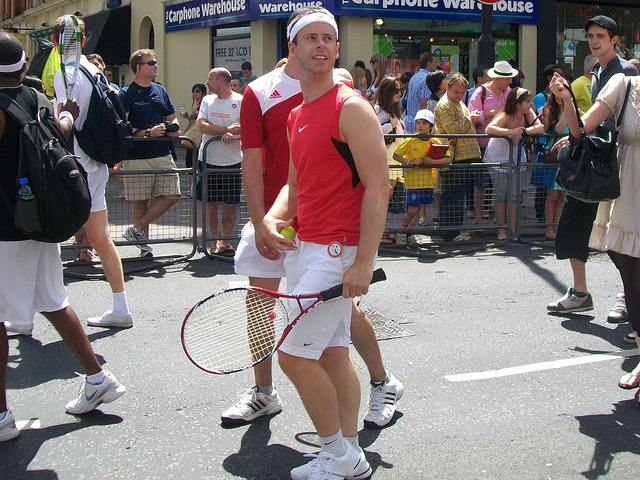Describe the objects in this image and their specific colors. I can see people in gray, brown, lightgray, and darkgray tones, people in gray, black, darkgray, and brown tones, people in gray, lightgray, maroon, and brown tones, tennis racket in gray, lightgray, darkgray, maroon, and black tones, and backpack in gray, black, and darkgray tones in this image. 